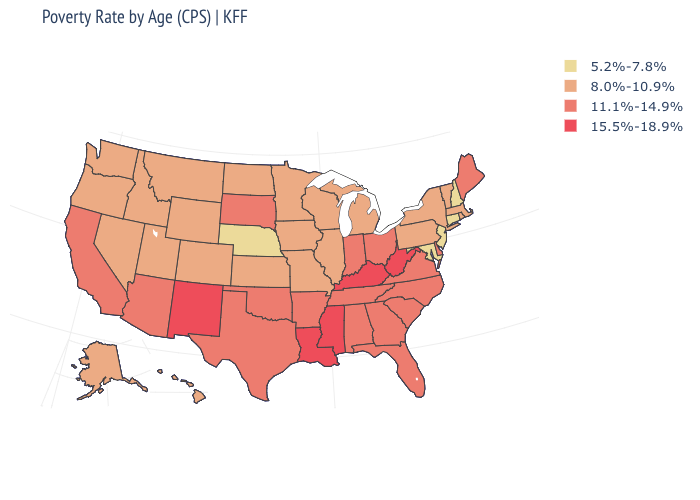Among the states that border Nevada , which have the lowest value?
Give a very brief answer. Idaho, Oregon, Utah. Name the states that have a value in the range 15.5%-18.9%?
Be succinct. Kentucky, Louisiana, Mississippi, New Mexico, West Virginia. Name the states that have a value in the range 8.0%-10.9%?
Concise answer only. Alaska, Colorado, Hawaii, Idaho, Illinois, Iowa, Kansas, Massachusetts, Michigan, Minnesota, Missouri, Montana, Nevada, New York, North Dakota, Oregon, Pennsylvania, Rhode Island, Utah, Vermont, Washington, Wisconsin, Wyoming. Does Minnesota have a higher value than Nebraska?
Be succinct. Yes. What is the highest value in the USA?
Concise answer only. 15.5%-18.9%. Which states have the lowest value in the MidWest?
Answer briefly. Nebraska. What is the value of Washington?
Give a very brief answer. 8.0%-10.9%. What is the lowest value in the USA?
Write a very short answer. 5.2%-7.8%. Is the legend a continuous bar?
Short answer required. No. Does Idaho have the same value as Connecticut?
Quick response, please. No. What is the value of Pennsylvania?
Concise answer only. 8.0%-10.9%. Does the first symbol in the legend represent the smallest category?
Concise answer only. Yes. Name the states that have a value in the range 5.2%-7.8%?
Answer briefly. Connecticut, Maryland, Nebraska, New Hampshire, New Jersey. What is the value of Alabama?
Quick response, please. 11.1%-14.9%. 